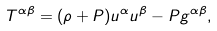Convert formula to latex. <formula><loc_0><loc_0><loc_500><loc_500>T ^ { \alpha \beta } = ( \rho + P ) u ^ { \alpha } u ^ { \beta } - P g ^ { \alpha \beta } ,</formula> 